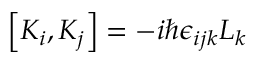<formula> <loc_0><loc_0><loc_500><loc_500>\left [ K _ { i } , K _ { j } \right ] = - i \hbar { \epsilon } _ { i j k } L _ { k }</formula> 